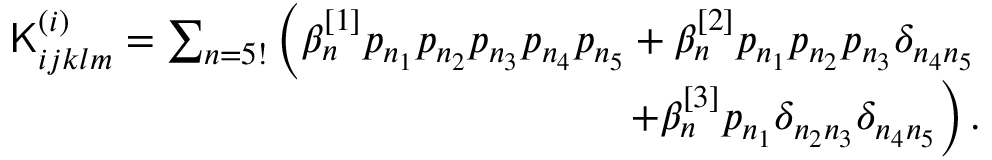<formula> <loc_0><loc_0><loc_500><loc_500>\begin{array} { r } { K _ { i j k l m } ^ { ( i ) } = \sum _ { n = 5 ! } \left ( \beta _ { n } ^ { [ 1 ] } p _ { n _ { 1 } } p _ { n _ { 2 } } p _ { n _ { 3 } } p _ { n _ { 4 } } p _ { n _ { 5 } } + \beta _ { n } ^ { [ 2 ] } p _ { n _ { 1 } } p _ { n _ { 2 } } p _ { n _ { 3 } } \delta _ { n _ { 4 } n _ { 5 } } } \\ { + \beta _ { n } ^ { [ 3 ] } p _ { n _ { 1 } } \delta _ { n _ { 2 } n _ { 3 } } \delta _ { n _ { 4 } n _ { 5 } } \right ) . } \end{array}</formula> 